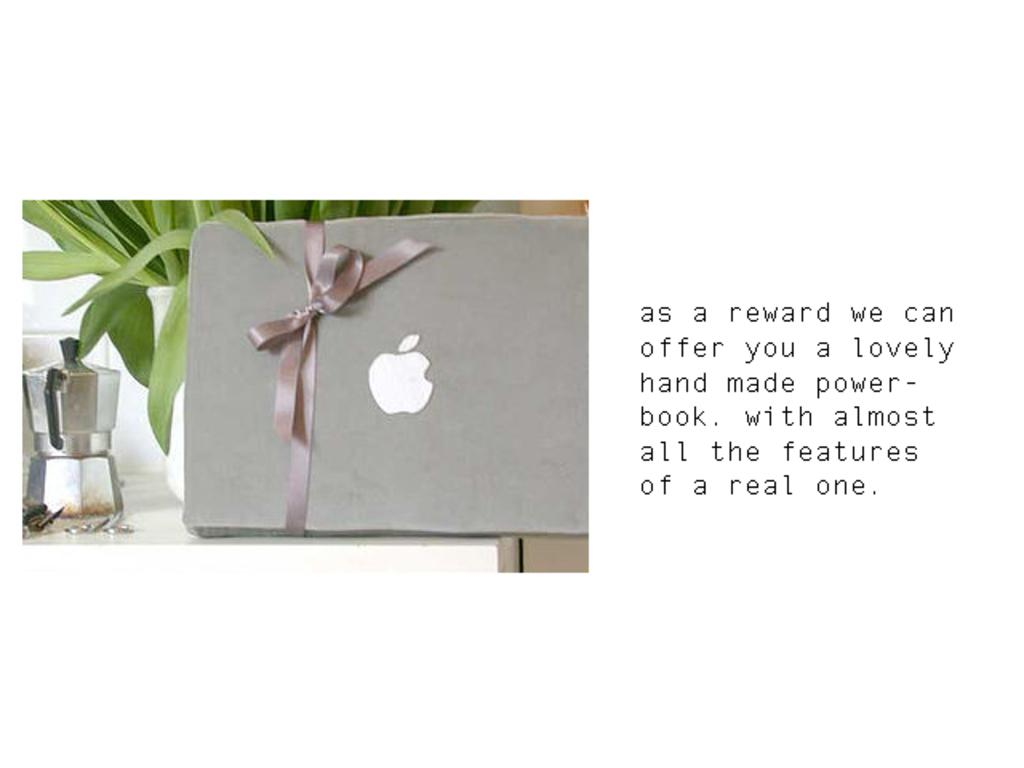Provide a one-sentence caption for the provided image. A ribbon wrapped around a box with the Apple company logo on it. 